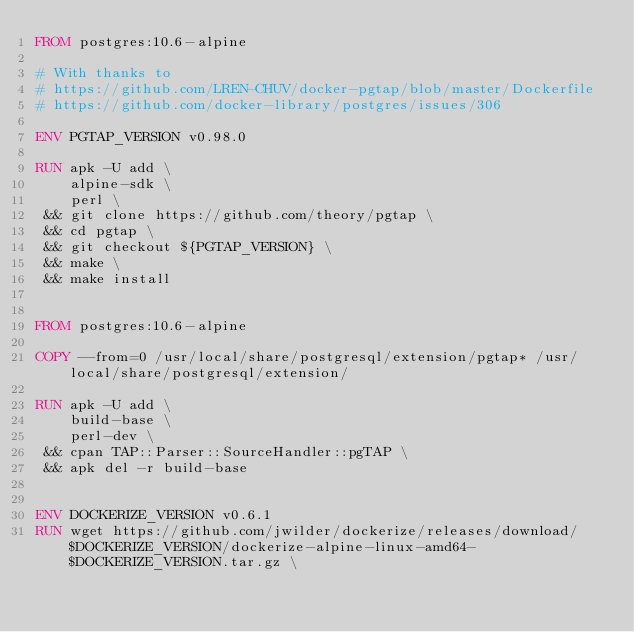Convert code to text. <code><loc_0><loc_0><loc_500><loc_500><_Dockerfile_>FROM postgres:10.6-alpine

# With thanks to
# https://github.com/LREN-CHUV/docker-pgtap/blob/master/Dockerfile
# https://github.com/docker-library/postgres/issues/306

ENV PGTAP_VERSION v0.98.0

RUN apk -U add \
    alpine-sdk \
    perl \
 && git clone https://github.com/theory/pgtap \
 && cd pgtap \
 && git checkout ${PGTAP_VERSION} \
 && make \
 && make install


FROM postgres:10.6-alpine

COPY --from=0 /usr/local/share/postgresql/extension/pgtap* /usr/local/share/postgresql/extension/

RUN apk -U add \
    build-base \
    perl-dev \
 && cpan TAP::Parser::SourceHandler::pgTAP \
 && apk del -r build-base


ENV DOCKERIZE_VERSION v0.6.1
RUN wget https://github.com/jwilder/dockerize/releases/download/$DOCKERIZE_VERSION/dockerize-alpine-linux-amd64-$DOCKERIZE_VERSION.tar.gz \</code> 